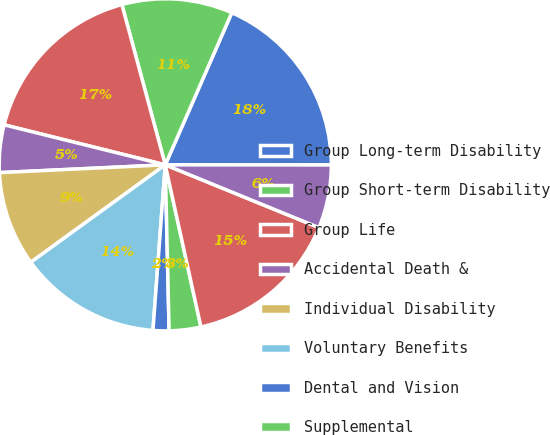<chart> <loc_0><loc_0><loc_500><loc_500><pie_chart><fcel>Group Long-term Disability<fcel>Group Short-term Disability<fcel>Group Life<fcel>Accidental Death &<fcel>Individual Disability<fcel>Voluntary Benefits<fcel>Dental and Vision<fcel>Supplemental<fcel>Accident Sickness and<fcel>Life<nl><fcel>18.45%<fcel>10.77%<fcel>16.92%<fcel>4.62%<fcel>9.23%<fcel>13.84%<fcel>1.55%<fcel>3.08%<fcel>15.38%<fcel>6.16%<nl></chart> 